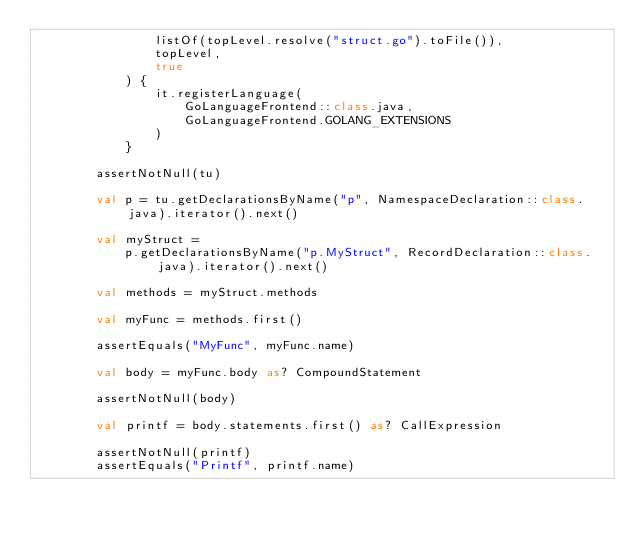Convert code to text. <code><loc_0><loc_0><loc_500><loc_500><_Kotlin_>                listOf(topLevel.resolve("struct.go").toFile()),
                topLevel,
                true
            ) {
                it.registerLanguage(
                    GoLanguageFrontend::class.java,
                    GoLanguageFrontend.GOLANG_EXTENSIONS
                )
            }

        assertNotNull(tu)

        val p = tu.getDeclarationsByName("p", NamespaceDeclaration::class.java).iterator().next()

        val myStruct =
            p.getDeclarationsByName("p.MyStruct", RecordDeclaration::class.java).iterator().next()

        val methods = myStruct.methods

        val myFunc = methods.first()

        assertEquals("MyFunc", myFunc.name)

        val body = myFunc.body as? CompoundStatement

        assertNotNull(body)

        val printf = body.statements.first() as? CallExpression

        assertNotNull(printf)
        assertEquals("Printf", printf.name)</code> 